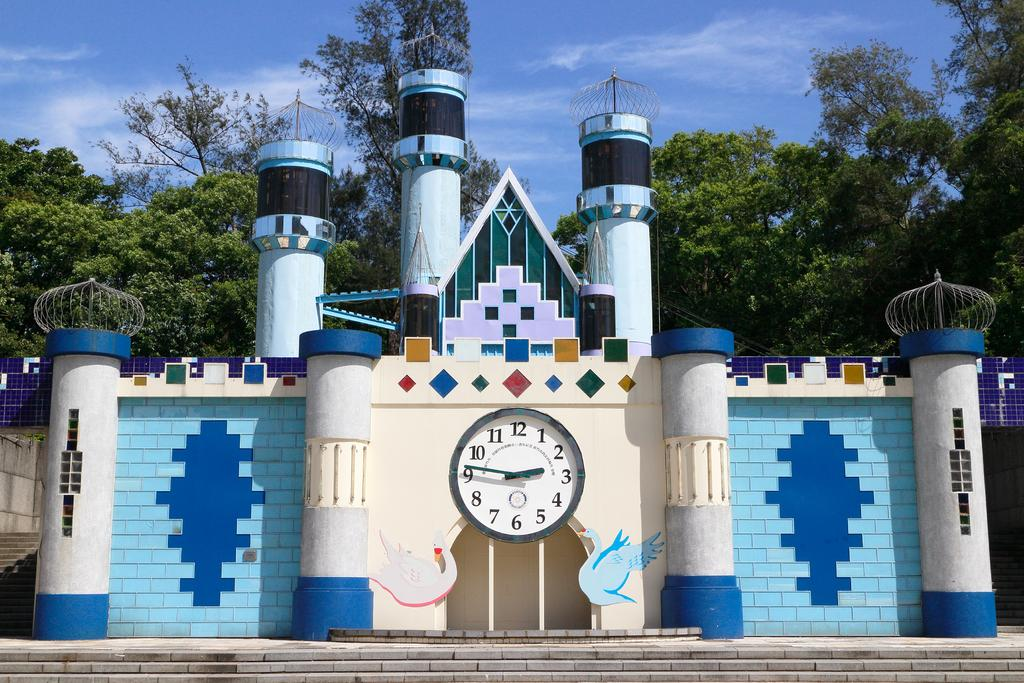Provide a one-sentence caption for the provided image. A colorful brick castle building with a large analog clock at center with the numbers 1-12 on the clock. 